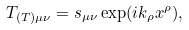Convert formula to latex. <formula><loc_0><loc_0><loc_500><loc_500>T _ { ( T ) \mu \nu } = s _ { \mu \nu } \exp ( i k _ { \rho } x ^ { \rho } ) ,</formula> 